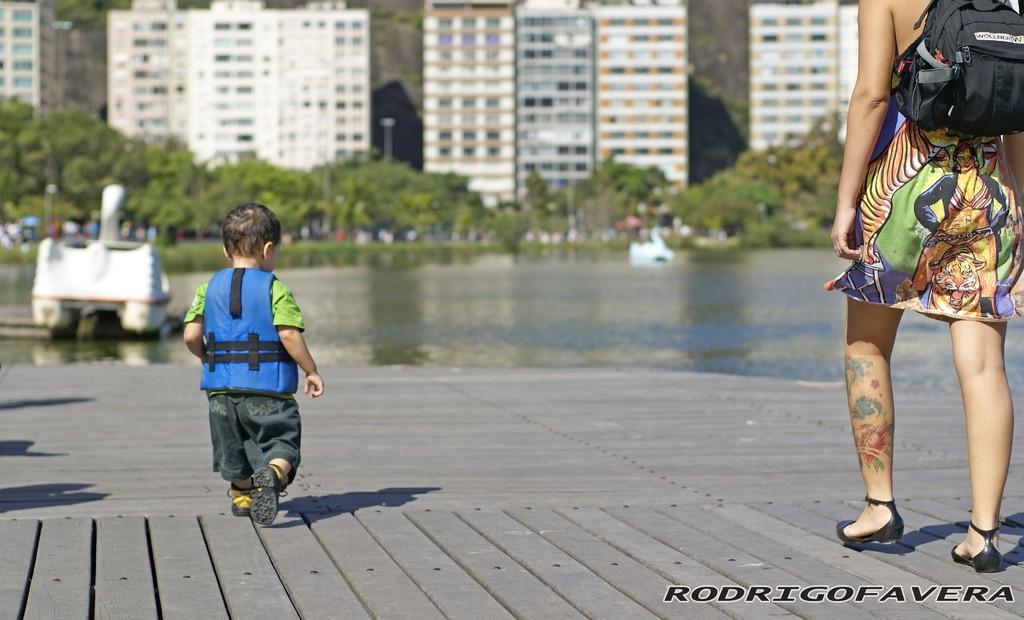Can you describe this image briefly? In this picture there is a boy who is waking. There is a woman who is wearing a bag. There is a water. There are some plants at the background and a building. 